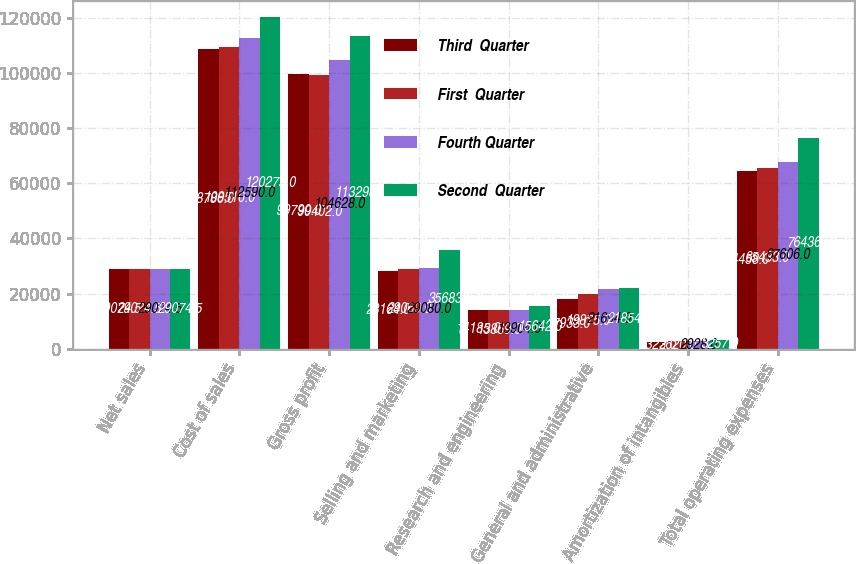Convert chart to OTSL. <chart><loc_0><loc_0><loc_500><loc_500><stacked_bar_chart><ecel><fcel>Net sales<fcel>Cost of sales<fcel>Gross profit<fcel>Selling and marketing<fcel>Research and engineering<fcel>General and administrative<fcel>Amortization of intangibles<fcel>Total operating expenses<nl><fcel>Third  Quarter<fcel>29074.5<fcel>108786<fcel>99790<fcel>28164<fcel>14185<fcel>17933<fcel>2323<fcel>64458<nl><fcel>First  Quarter<fcel>29074.5<fcel>109510<fcel>99402<fcel>29069<fcel>13869<fcel>19875<fcel>2620<fcel>65433<nl><fcel>Fourth Quarter<fcel>29074.5<fcel>112590<fcel>104628<fcel>29080<fcel>13904<fcel>21694<fcel>2928<fcel>67606<nl><fcel>Second  Quarter<fcel>29074.5<fcel>120275<fcel>113298<fcel>35683<fcel>15642<fcel>21854<fcel>3257<fcel>76436<nl></chart> 